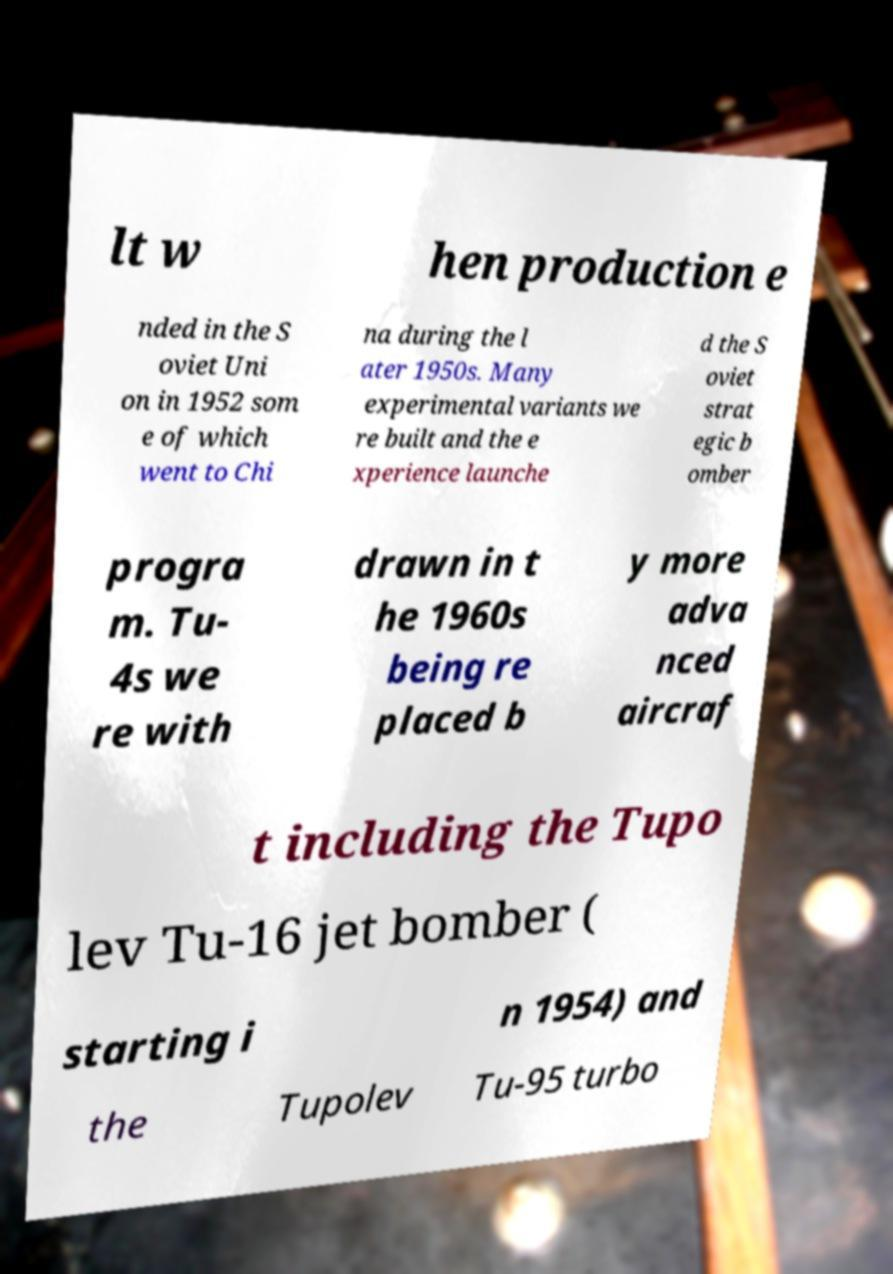I need the written content from this picture converted into text. Can you do that? lt w hen production e nded in the S oviet Uni on in 1952 som e of which went to Chi na during the l ater 1950s. Many experimental variants we re built and the e xperience launche d the S oviet strat egic b omber progra m. Tu- 4s we re with drawn in t he 1960s being re placed b y more adva nced aircraf t including the Tupo lev Tu-16 jet bomber ( starting i n 1954) and the Tupolev Tu-95 turbo 